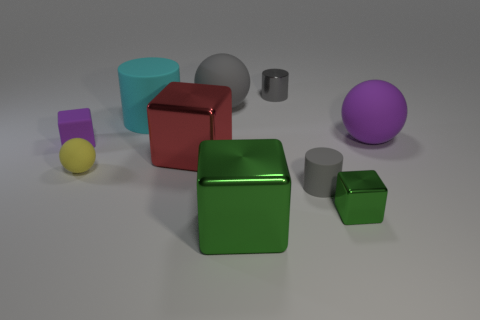Subtract all cylinders. How many objects are left? 7 Add 7 small gray matte spheres. How many small gray matte spheres exist? 7 Subtract 0 blue cubes. How many objects are left? 10 Subtract all big blocks. Subtract all large rubber cylinders. How many objects are left? 7 Add 2 purple rubber things. How many purple rubber things are left? 4 